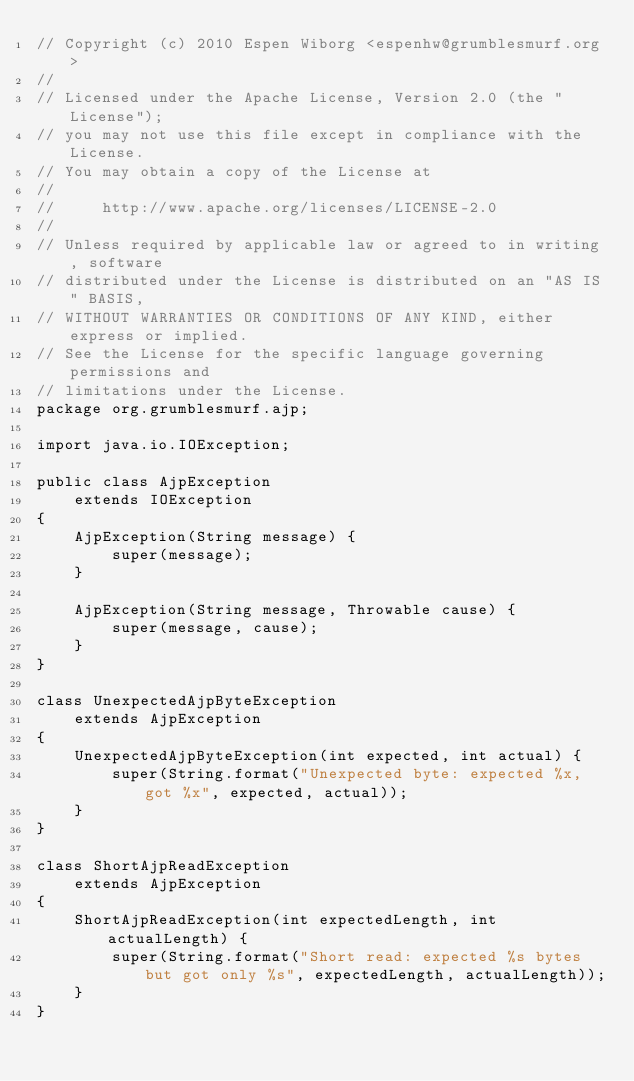<code> <loc_0><loc_0><loc_500><loc_500><_Java_>// Copyright (c) 2010 Espen Wiborg <espenhw@grumblesmurf.org>
//
// Licensed under the Apache License, Version 2.0 (the "License");
// you may not use this file except in compliance with the License.
// You may obtain a copy of the License at
//
//     http://www.apache.org/licenses/LICENSE-2.0
//
// Unless required by applicable law or agreed to in writing, software
// distributed under the License is distributed on an "AS IS" BASIS,
// WITHOUT WARRANTIES OR CONDITIONS OF ANY KIND, either express or implied.
// See the License for the specific language governing permissions and
// limitations under the License.
package org.grumblesmurf.ajp;

import java.io.IOException;

public class AjpException
    extends IOException 
{
    AjpException(String message) {
        super(message);
    }

    AjpException(String message, Throwable cause) {
        super(message, cause);
    }
}

class UnexpectedAjpByteException
    extends AjpException 
{
    UnexpectedAjpByteException(int expected, int actual) {
        super(String.format("Unexpected byte: expected %x, got %x", expected, actual));
    }
}

class ShortAjpReadException
    extends AjpException 
{
    ShortAjpReadException(int expectedLength, int actualLength) {
        super(String.format("Short read: expected %s bytes but got only %s", expectedLength, actualLength));
    }
}
</code> 